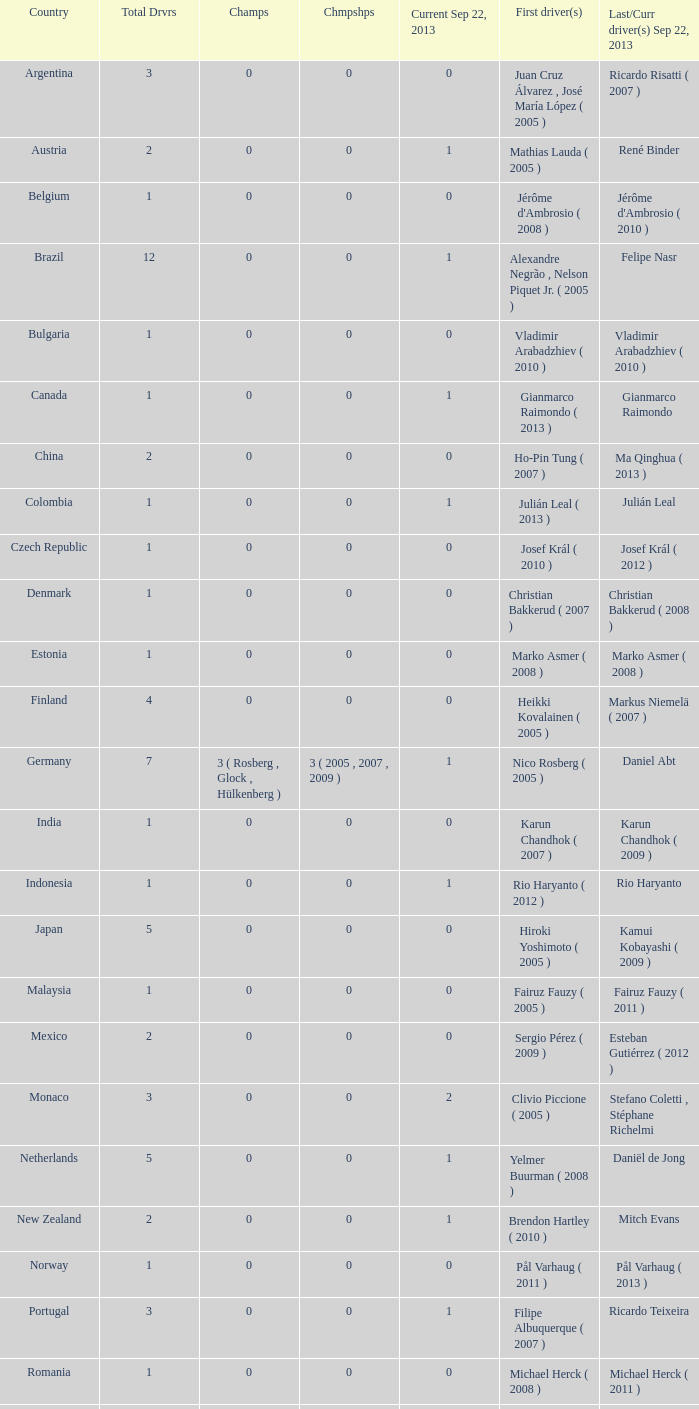How many champions were there when the last driver for September 22, 2013 was vladimir arabadzhiev ( 2010 )? 0.0. 